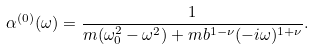Convert formula to latex. <formula><loc_0><loc_0><loc_500><loc_500>\alpha ^ { ( 0 ) } ( \omega ) = \frac { 1 } { m ( \omega _ { 0 } ^ { 2 } - \omega ^ { 2 } ) + m b ^ { 1 - \nu } ( - i \omega ) ^ { 1 + \nu } } .</formula> 